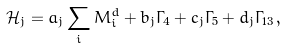Convert formula to latex. <formula><loc_0><loc_0><loc_500><loc_500>\mathcal { H } _ { j } = a _ { j } \sum _ { i } M ^ { d } _ { i } + b _ { j } \Gamma _ { 4 } + c _ { j } \Gamma _ { 5 } + d _ { j } \Gamma _ { 1 3 } \, ,</formula> 